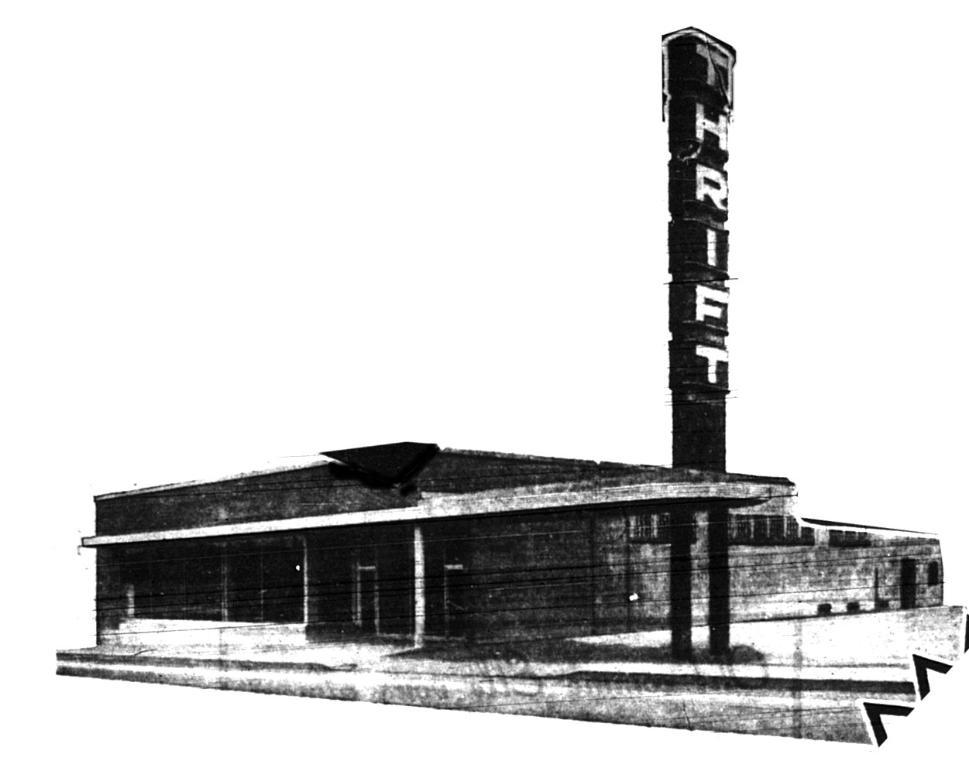What type of editing has been done to the image? The image is edited, but the specific type of editing is not mentioned in the facts. What can be seen in the picture besides the editing? There is a building in the picture. What color is the surface of the image? The image has a white surface. What color is the background of the image? The image has a white background. What type of copper material is present in the image? There is no copper material present in the image. Can you see a wristwatch on the building in the image? There is no wristwatch or any other accessory visible on the building in the image. 